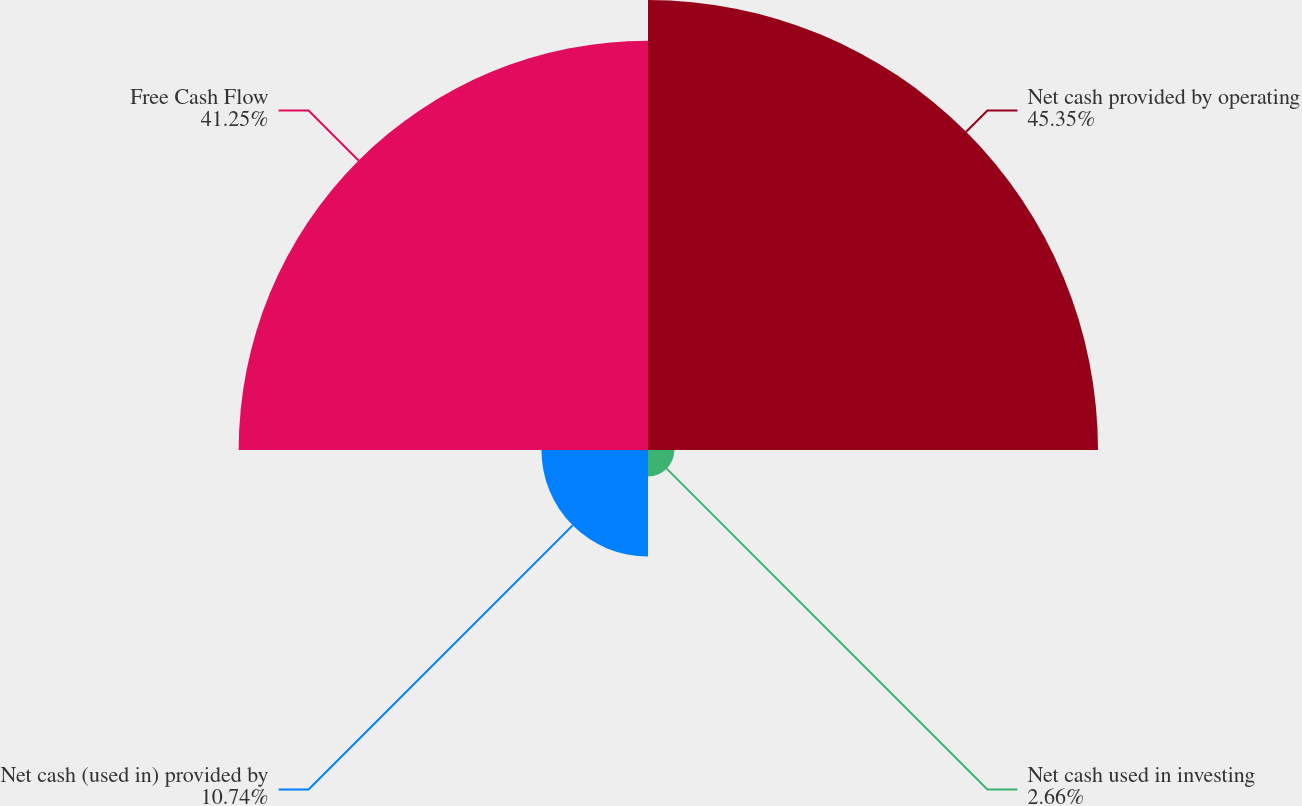Convert chart to OTSL. <chart><loc_0><loc_0><loc_500><loc_500><pie_chart><fcel>Net cash provided by operating<fcel>Net cash used in investing<fcel>Net cash (used in) provided by<fcel>Free Cash Flow<nl><fcel>45.35%<fcel>2.66%<fcel>10.74%<fcel>41.25%<nl></chart> 